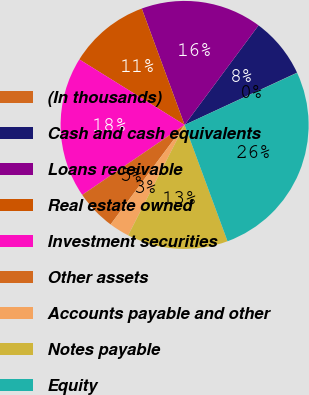Convert chart. <chart><loc_0><loc_0><loc_500><loc_500><pie_chart><fcel>(In thousands)<fcel>Cash and cash equivalents<fcel>Loans receivable<fcel>Real estate owned<fcel>Investment securities<fcel>Other assets<fcel>Accounts payable and other<fcel>Notes payable<fcel>Equity<nl><fcel>0.03%<fcel>7.9%<fcel>15.78%<fcel>10.53%<fcel>18.4%<fcel>5.28%<fcel>2.65%<fcel>13.15%<fcel>26.27%<nl></chart> 